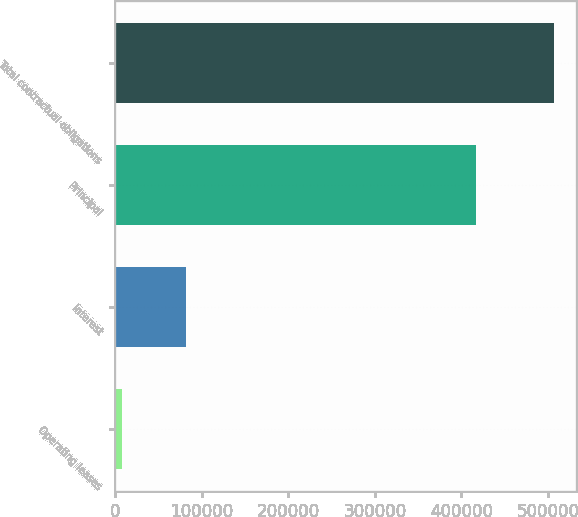<chart> <loc_0><loc_0><loc_500><loc_500><bar_chart><fcel>Operating leases<fcel>Interest<fcel>Principal<fcel>Total contractual obligations<nl><fcel>8336<fcel>81855<fcel>416758<fcel>506949<nl></chart> 